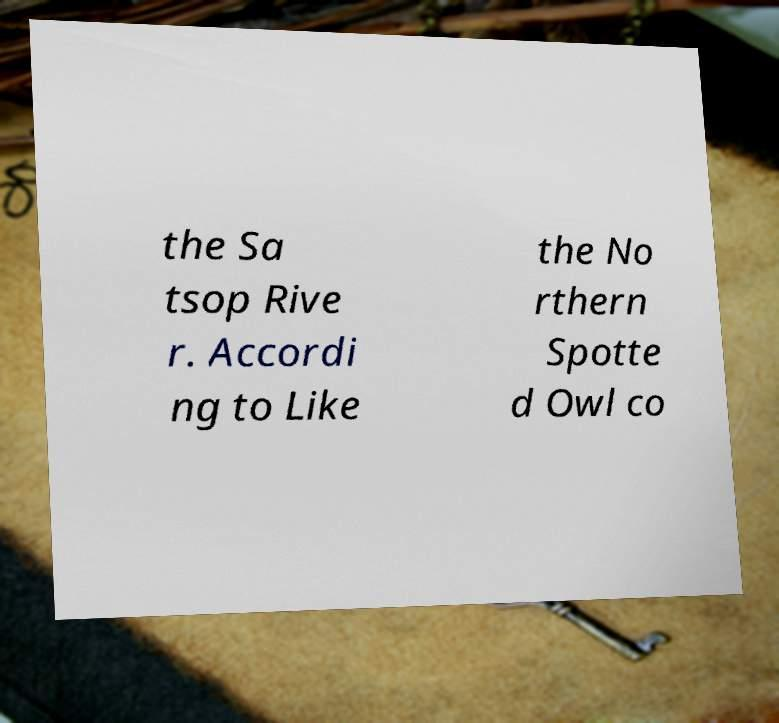Can you accurately transcribe the text from the provided image for me? the Sa tsop Rive r. Accordi ng to Like the No rthern Spotte d Owl co 